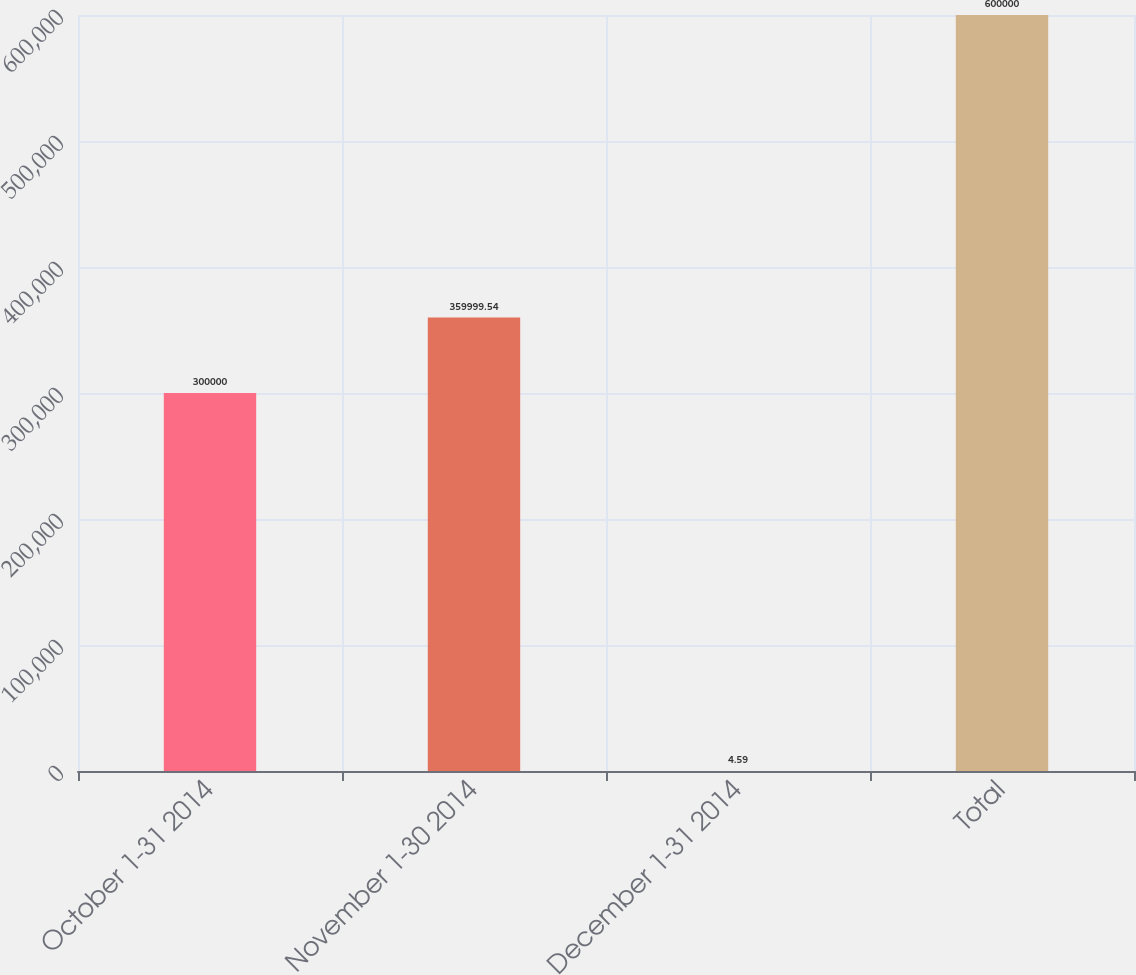Convert chart. <chart><loc_0><loc_0><loc_500><loc_500><bar_chart><fcel>October 1-31 2014<fcel>November 1-30 2014<fcel>December 1-31 2014<fcel>Total<nl><fcel>300000<fcel>360000<fcel>4.59<fcel>600000<nl></chart> 